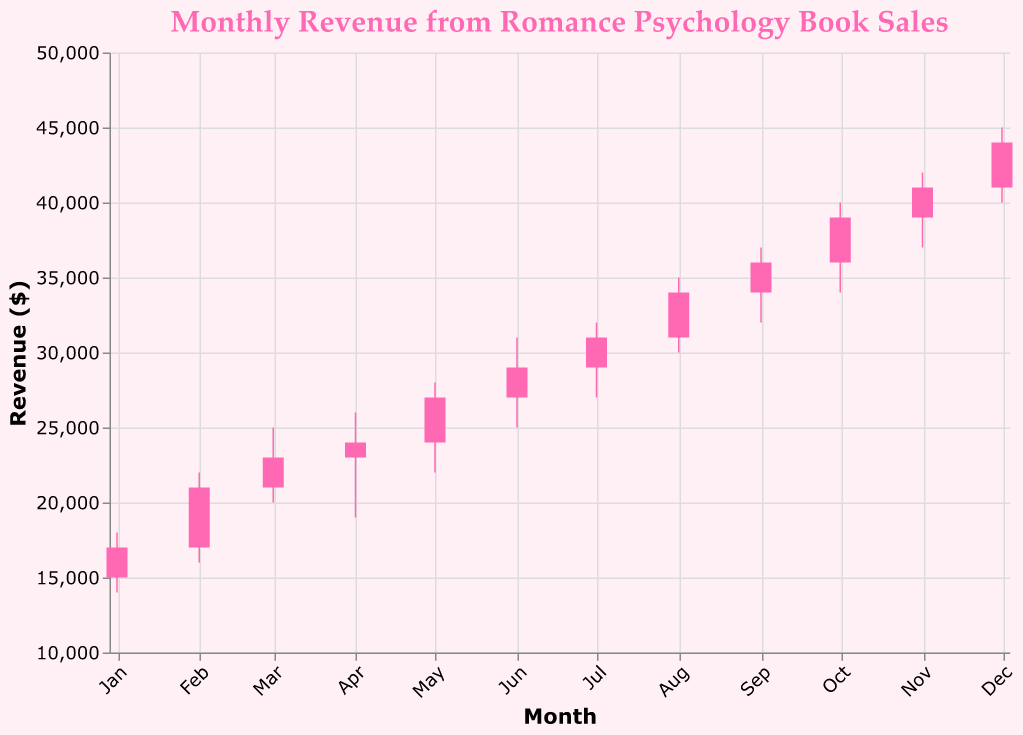What is the highest revenue recorded in any month? The highest revenue is found in the "High" values column and the highest value is 45000 in December 2023.
Answer: 45000 What is the lowest revenue recorded in any month? The lowest revenue is found in the "Low" values column, and the lowest value is 14000 in January 2023.
Answer: 14000 During which month did the revenue open and close at the same value? The revenue always changes between the opening and closing values in the given data. Therefore, no month has the same open and close values.
Answer: No month Which month experienced the highest increase in revenue from open to close? To find the highest increase, subtract the "Open" value from the "Close" value for each month and identify the largest difference. November experienced the highest increase: 41000 - 39000 = 2000.
Answer: November Compare the opening revenues of January and December. Which is higher? January's opening value is 15000, and December's opening value is 41000.
Answer: December Which months had a closing revenue higher than their opening revenue? Compare the "Close" values with the "Open" values for each month and list those where "Close" is greater than "Open". The months are January, February, March, April, May, June, July, August, September, October, November, December.
Answer: All months Which month had the largest range in revenue (high - low)? The range is calculated by subtracting "Low" from "High" for each month. December had the largest range: 45000 - 40000 = 5000.
Answer: December What were the opening and closing revenues for October? The opening revenue for October is 36000, and the closing revenue is 39000.
Answer: Opening: 36000, Closing: 39000 What's the difference between the highest closing revenue and the lowest closing revenue? Subtract the lowest closing revenue from the highest closing revenue. The highest closing revenue is in December (44000), and the lowest is in January (17000). So, 44000 - 17000 = 27000.
Answer: 27000 How did the revenue trend from January to December? Is it generally increasing, decreasing, or fluctuating? Observing the "Close" values from January (17000) to December (44000), there is a general increasing trend.
Answer: Increasing 